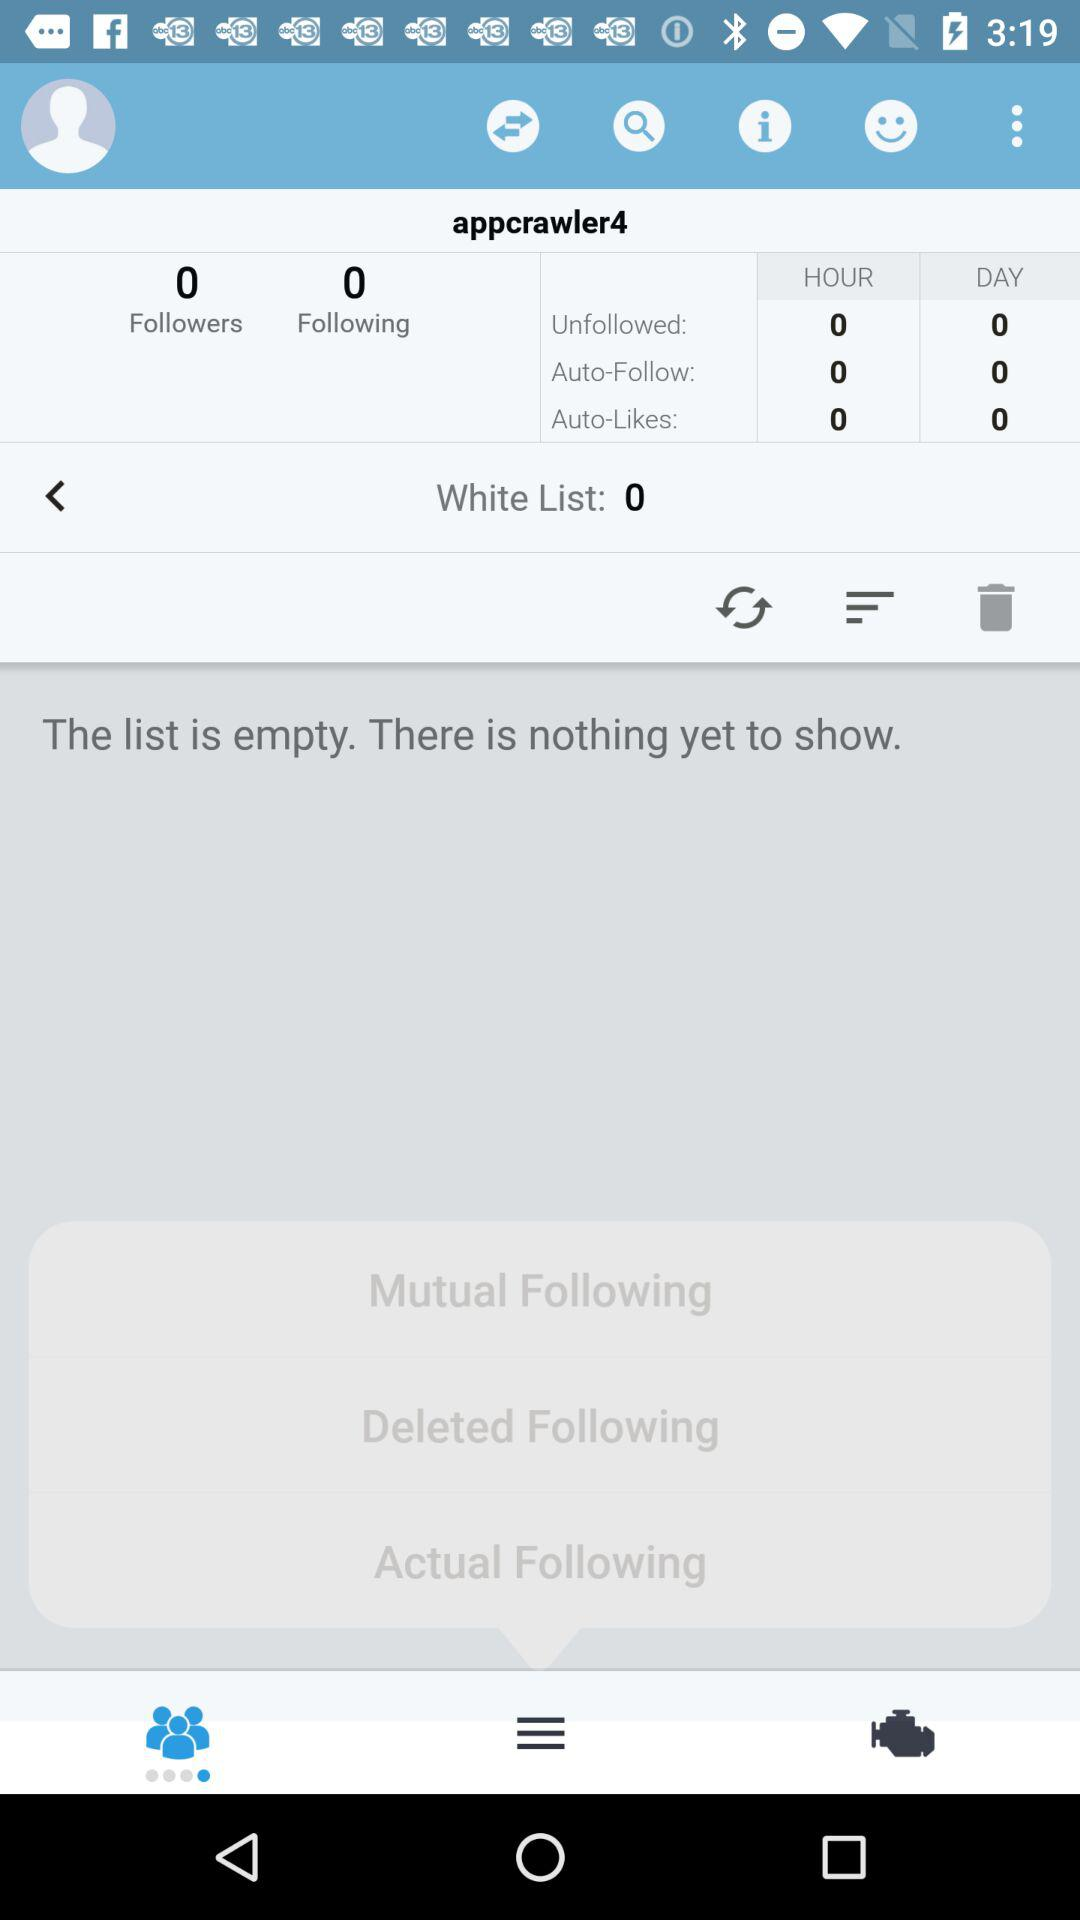How many followers are there? There are zero followers. 